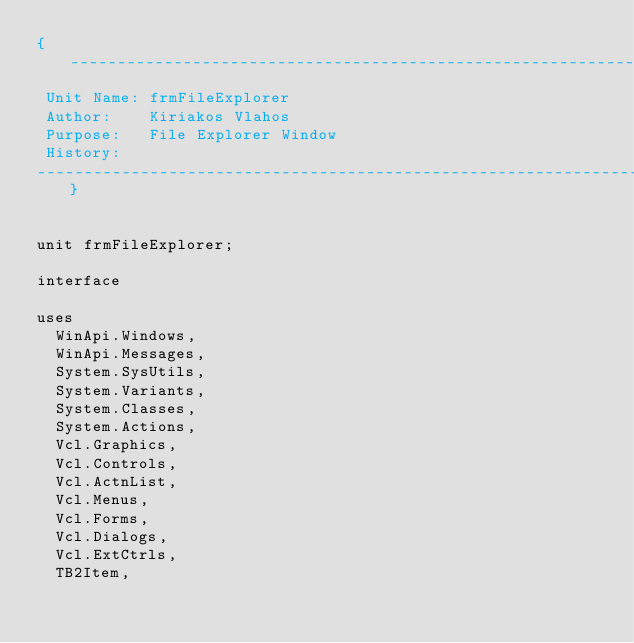Convert code to text. <code><loc_0><loc_0><loc_500><loc_500><_Pascal_>{-----------------------------------------------------------------------------
 Unit Name: frmFileExplorer
 Author:    Kiriakos Vlahos
 Purpose:   File Explorer Window
 History:
-----------------------------------------------------------------------------}


unit frmFileExplorer; 

interface

uses
  WinApi.Windows,
  WinApi.Messages,
  System.SysUtils,
  System.Variants,
  System.Classes,
  System.Actions,
  Vcl.Graphics,
  Vcl.Controls,
  Vcl.ActnList,
  Vcl.Menus,
  Vcl.Forms,
  Vcl.Dialogs,
  Vcl.ExtCtrls,
  TB2Item,</code> 